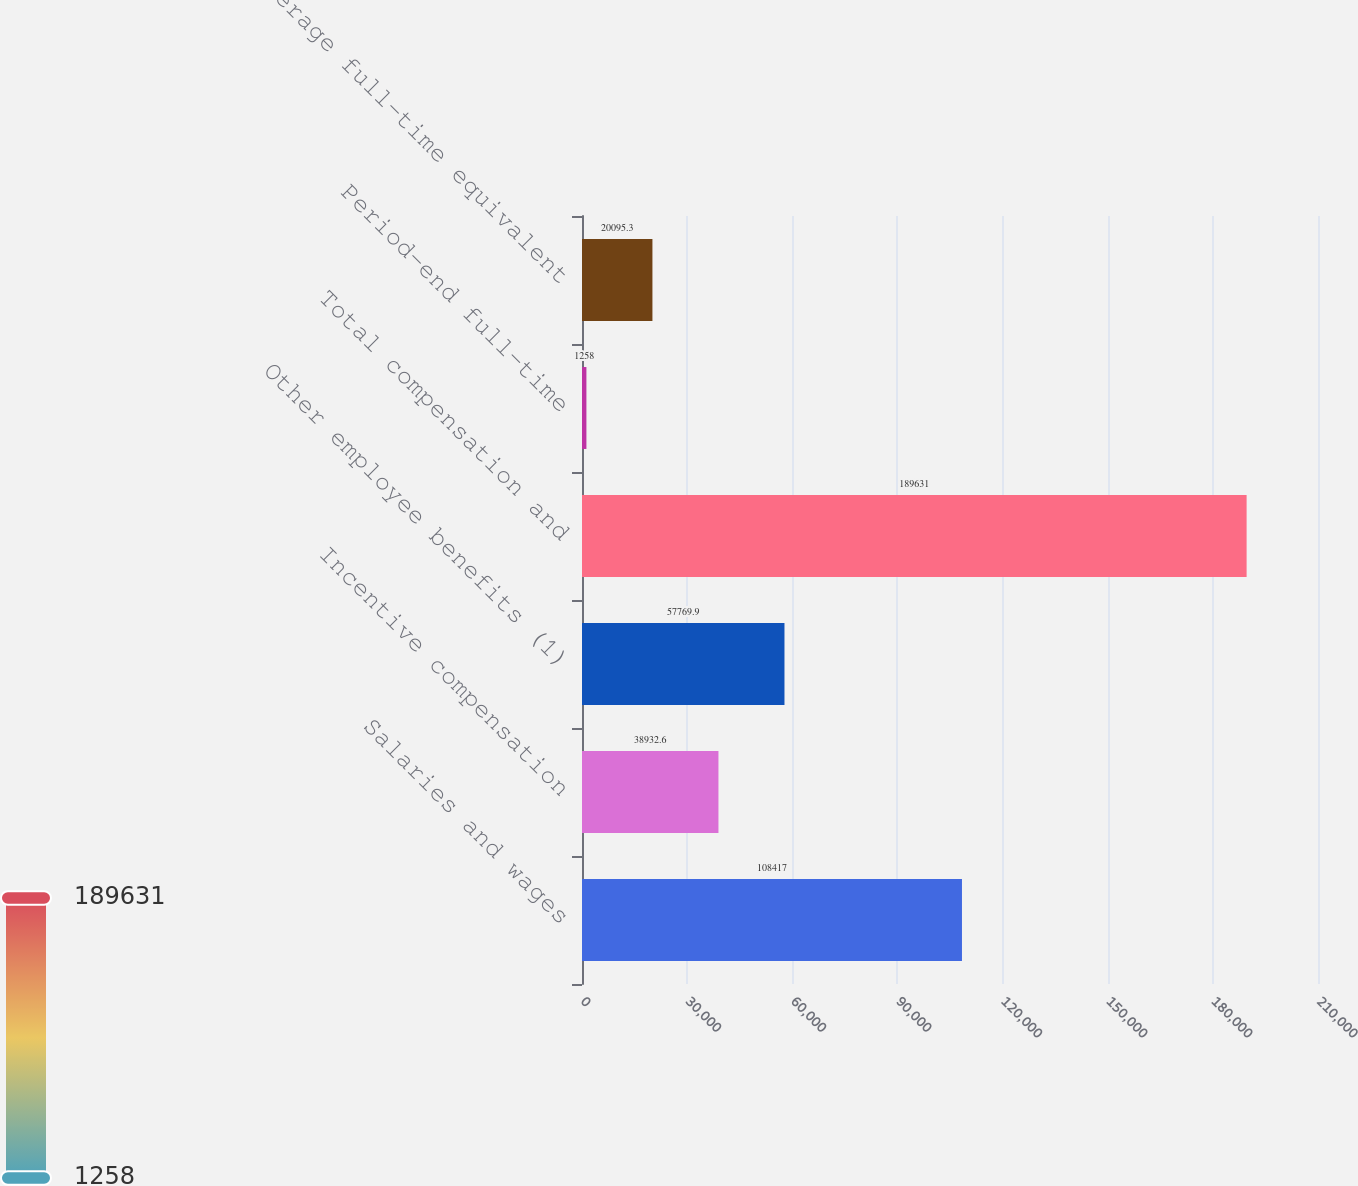Convert chart. <chart><loc_0><loc_0><loc_500><loc_500><bar_chart><fcel>Salaries and wages<fcel>Incentive compensation<fcel>Other employee benefits (1)<fcel>Total compensation and<fcel>Period-end full-time<fcel>Average full-time equivalent<nl><fcel>108417<fcel>38932.6<fcel>57769.9<fcel>189631<fcel>1258<fcel>20095.3<nl></chart> 